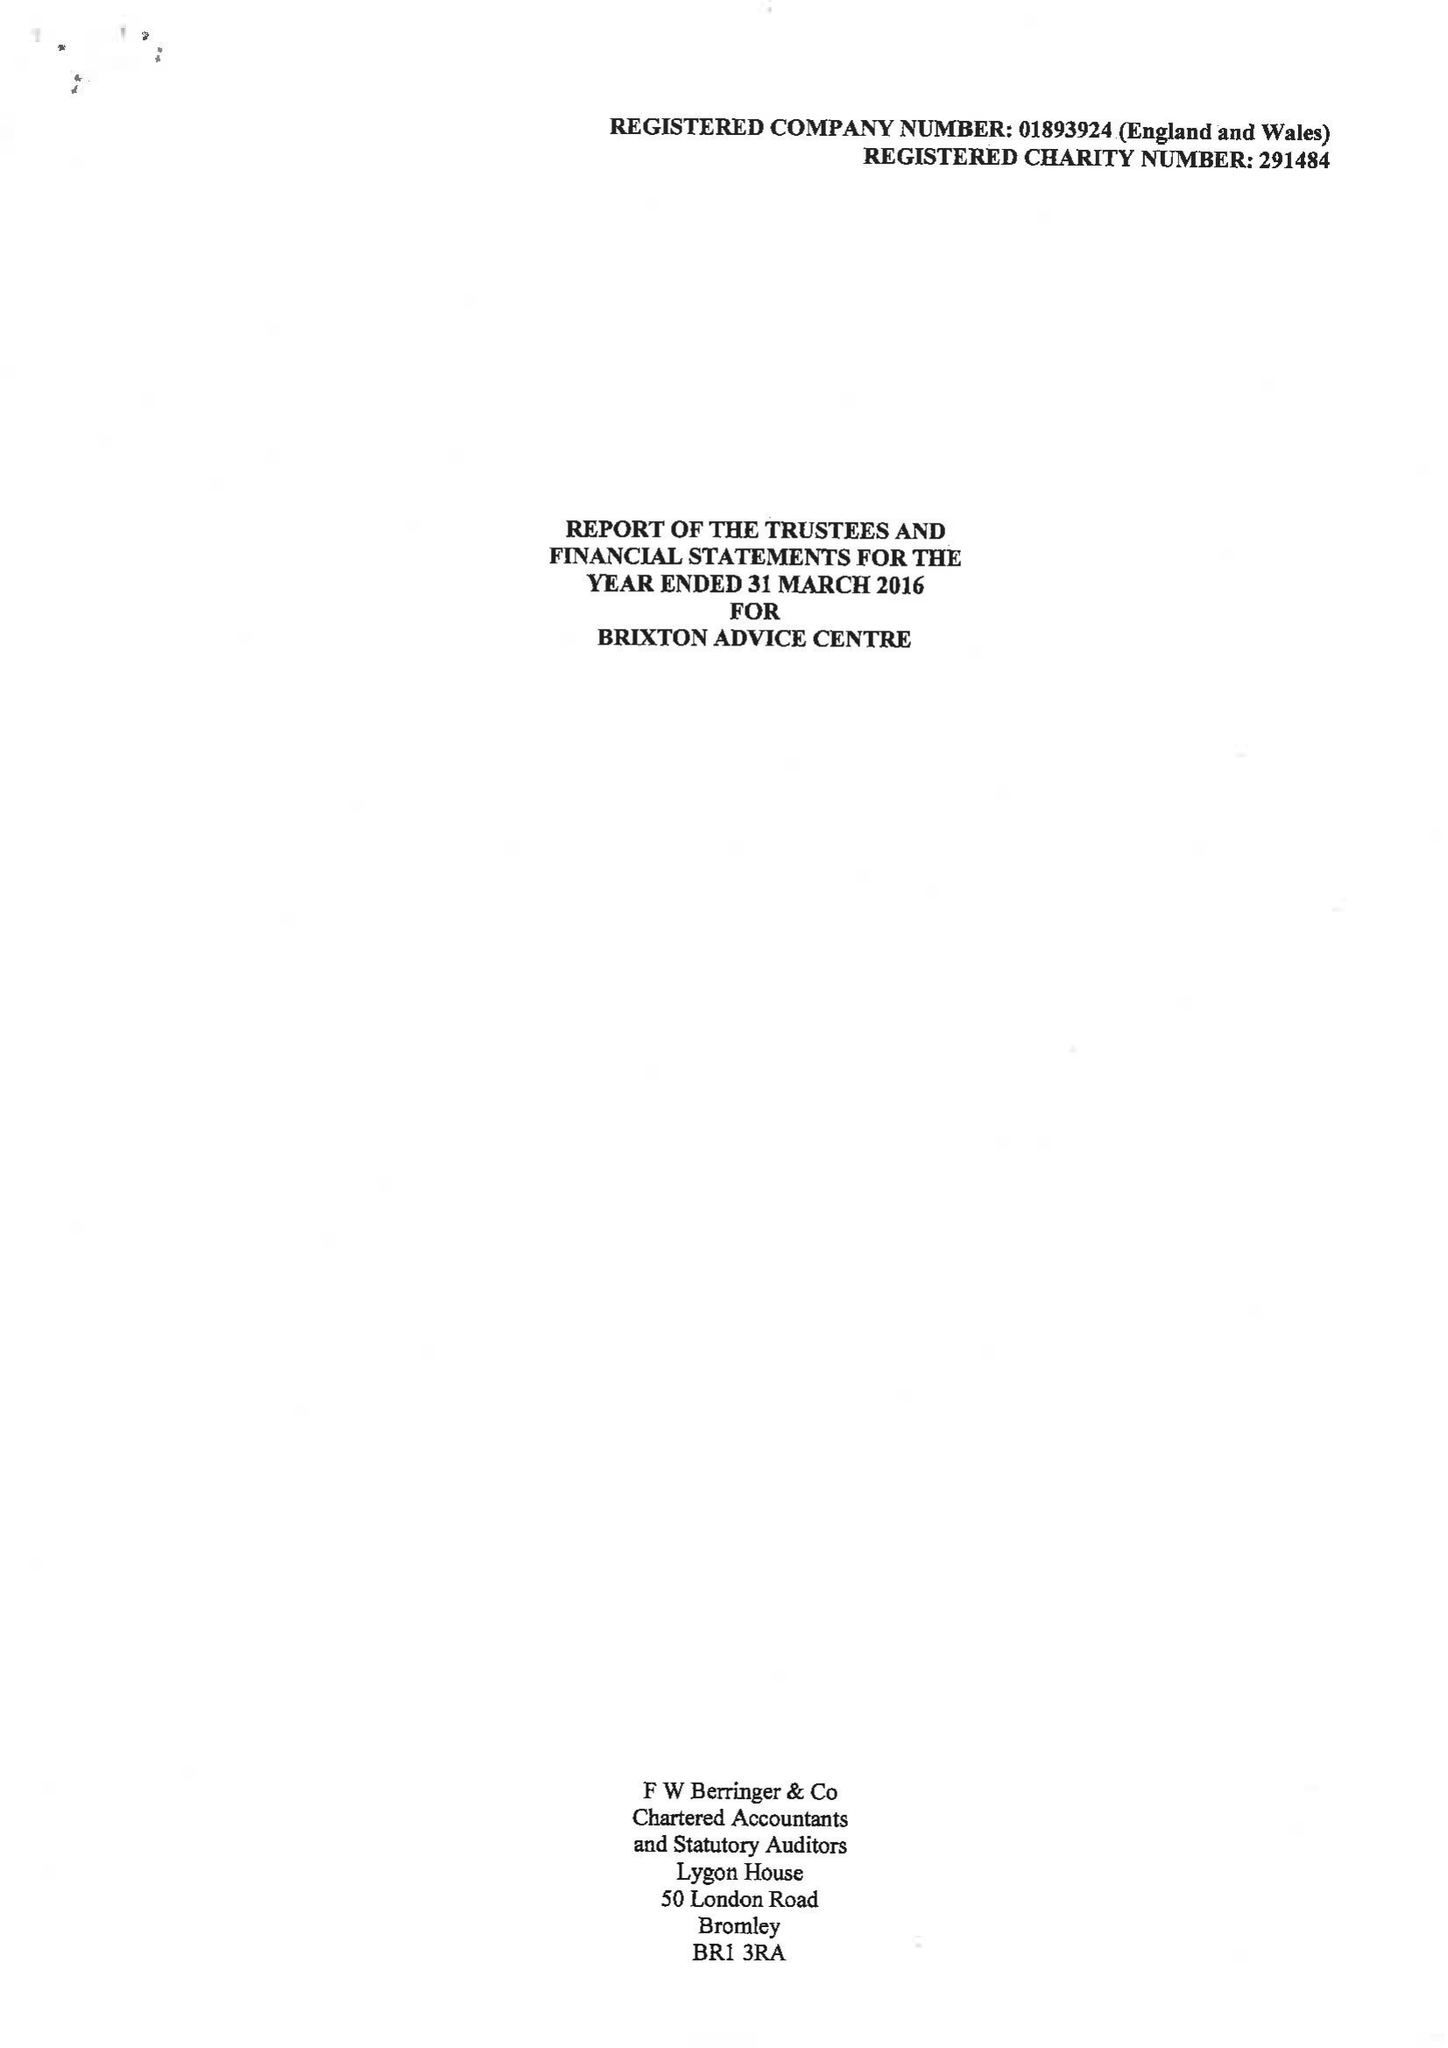What is the value for the charity_number?
Answer the question using a single word or phrase. 291484 